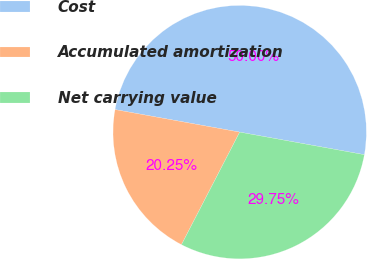Convert chart. <chart><loc_0><loc_0><loc_500><loc_500><pie_chart><fcel>Cost<fcel>Accumulated amortization<fcel>Net carrying value<nl><fcel>50.0%<fcel>20.25%<fcel>29.75%<nl></chart> 